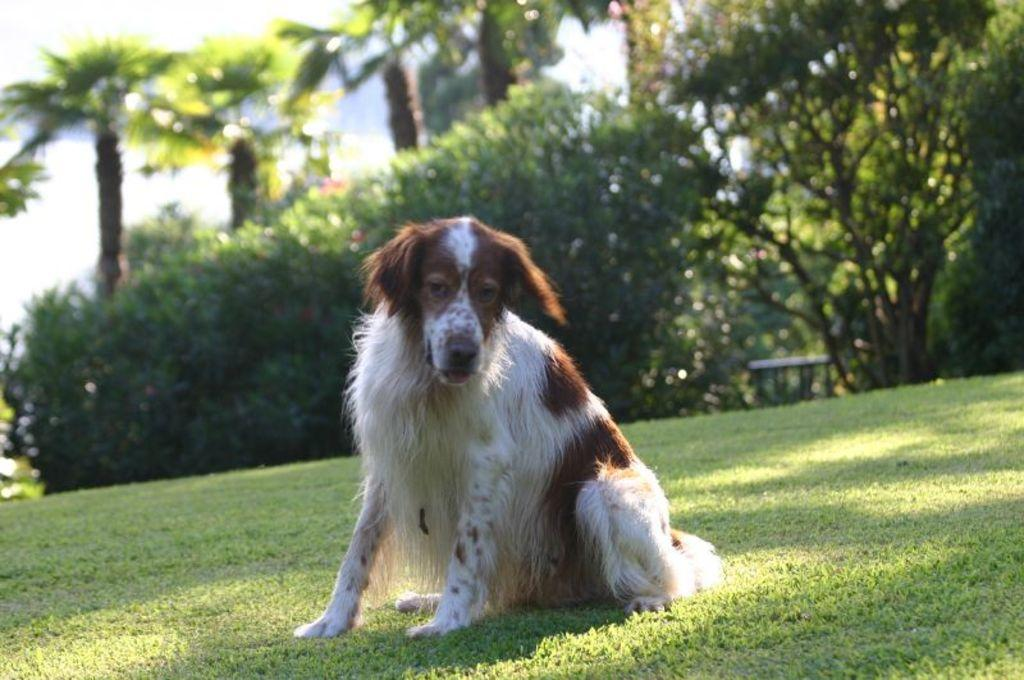What animal can be seen in the image? There is a dog in the image. What is the dog doing in the image? The dog is sitting on the grass. What can be seen in the background of the image? There are trees, plants, an unspecified object, and clouds in the sky in the background of the image. What historical event is being commemorated by the apple in the image? There is no apple present in the image, and therefore no historical event can be associated with it. 